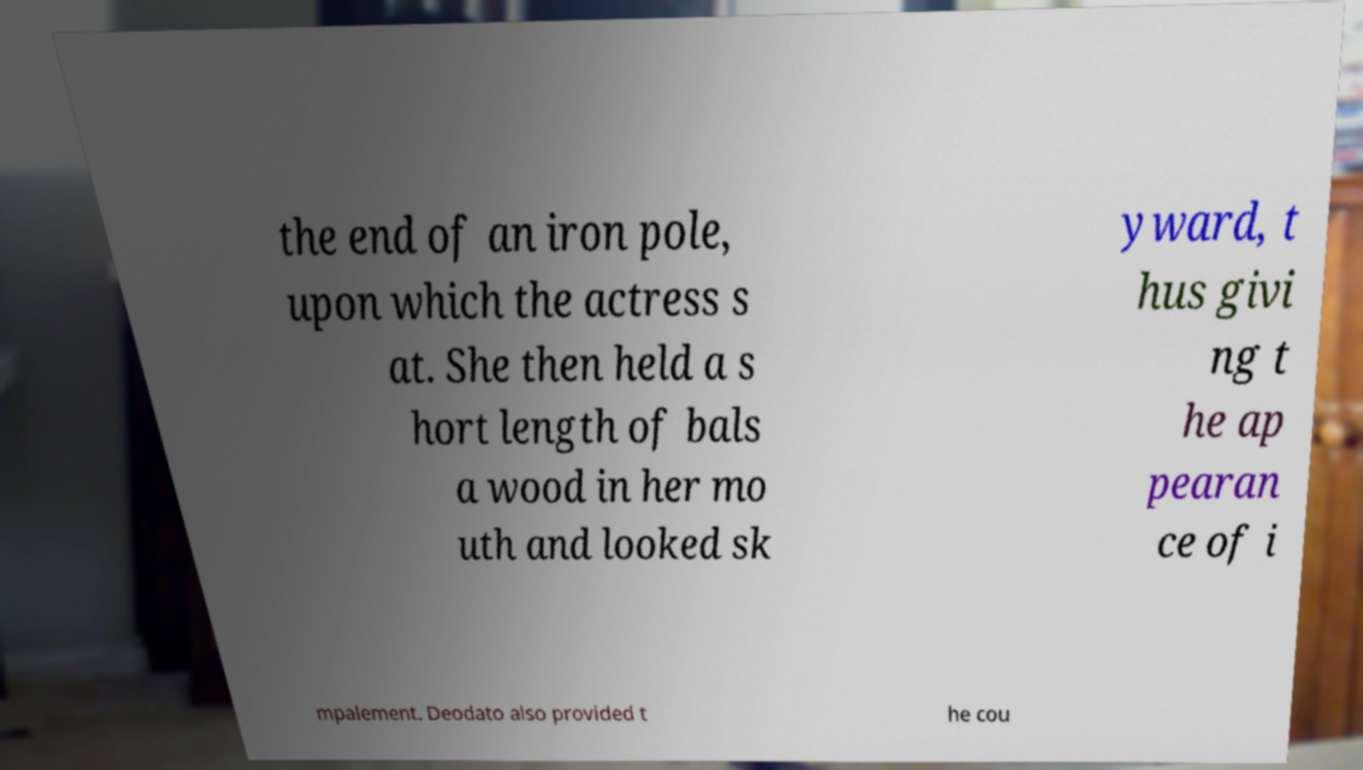For documentation purposes, I need the text within this image transcribed. Could you provide that? the end of an iron pole, upon which the actress s at. She then held a s hort length of bals a wood in her mo uth and looked sk yward, t hus givi ng t he ap pearan ce of i mpalement. Deodato also provided t he cou 